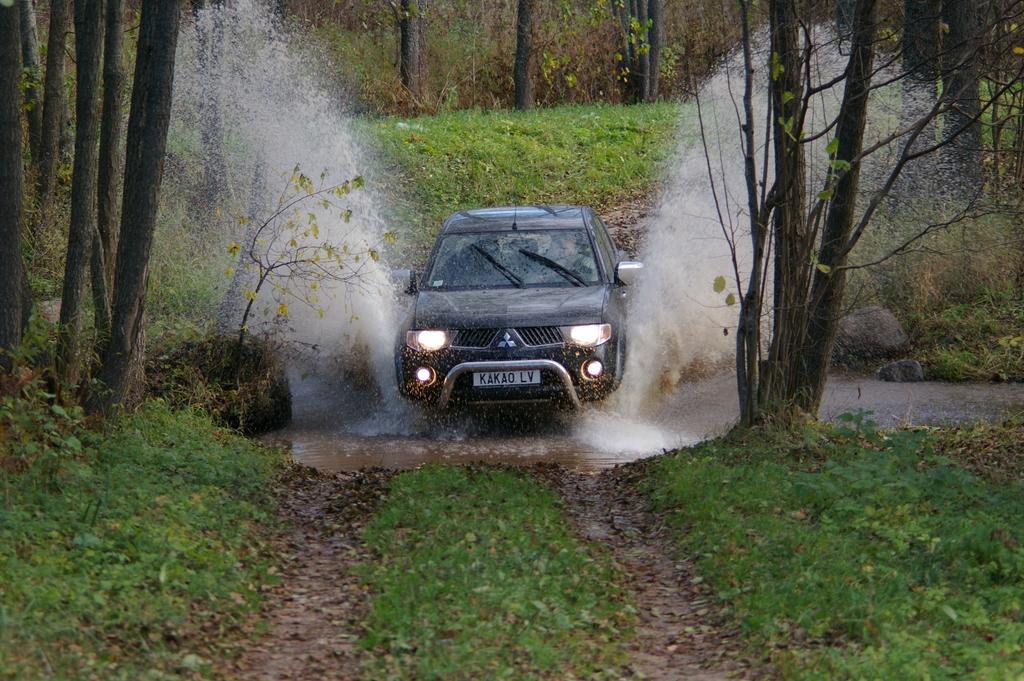Describe this image in one or two sentences. In the center of the image we can see a car and there is water. At the bottom there is grass. In the background there are trees. 